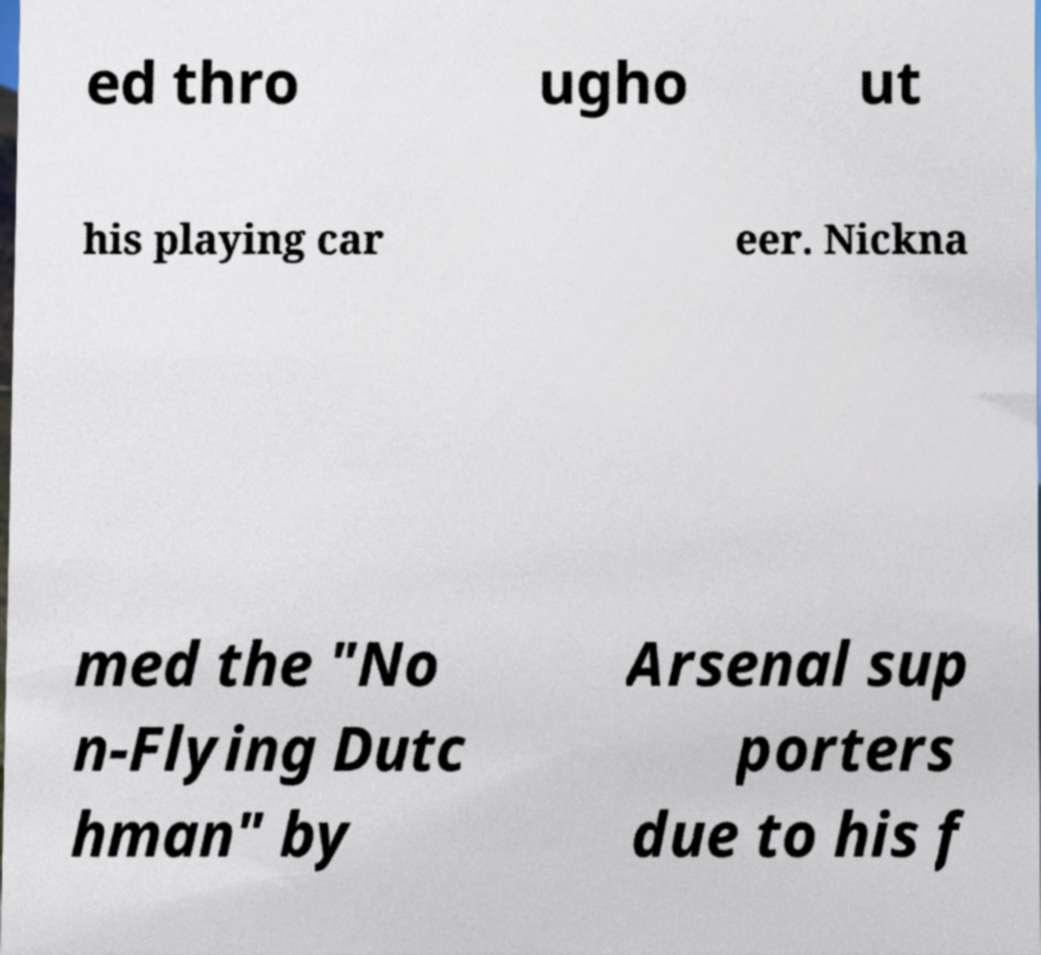Could you extract and type out the text from this image? ed thro ugho ut his playing car eer. Nickna med the "No n-Flying Dutc hman" by Arsenal sup porters due to his f 